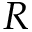Convert formula to latex. <formula><loc_0><loc_0><loc_500><loc_500>R</formula> 